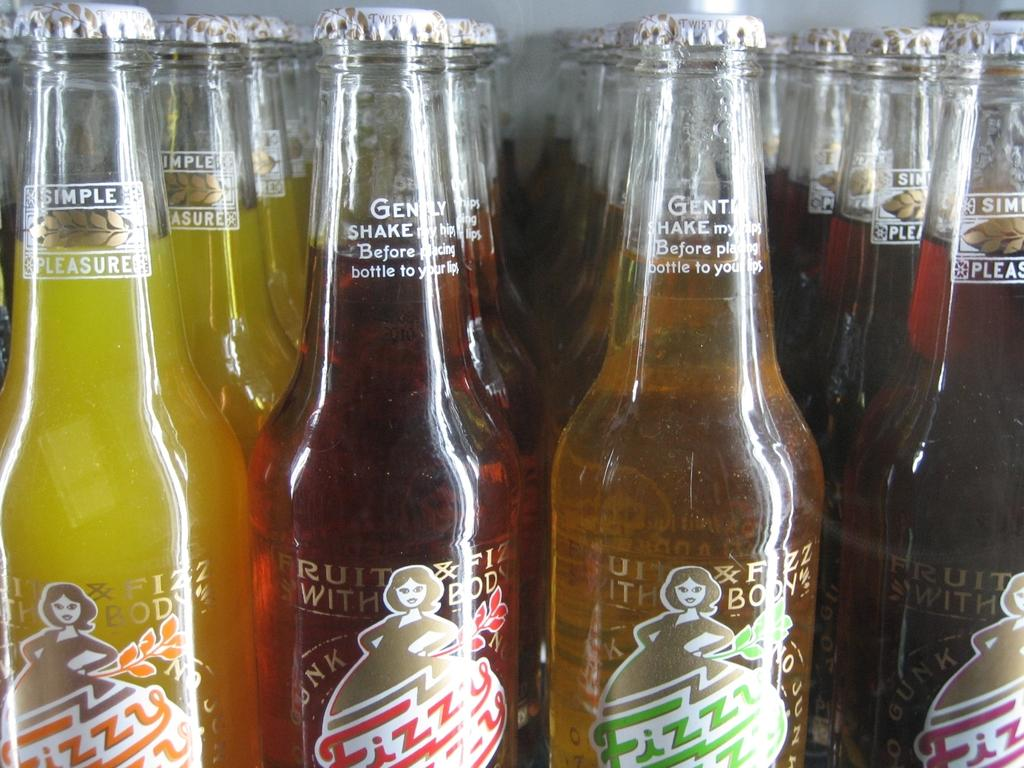Provide a one-sentence caption for the provided image. four different colored bottles of Fizzy brand soda. 